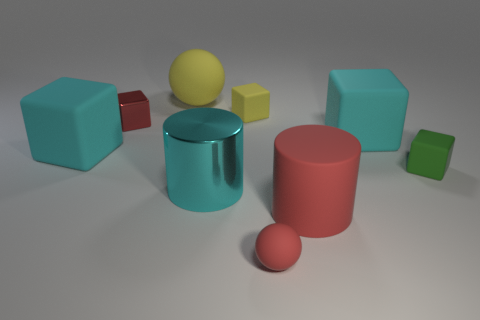There is a cylinder that is made of the same material as the small green object; what size is it?
Offer a very short reply. Large. How many gray shiny objects are the same shape as the small red matte object?
Offer a very short reply. 0. Are there more large cyan metallic cylinders that are to the right of the green thing than large cyan rubber objects that are to the right of the large yellow ball?
Your answer should be compact. No. There is a small metal cube; is its color the same as the cylinder that is to the right of the small red rubber sphere?
Offer a very short reply. Yes. There is a red cylinder that is the same size as the yellow ball; what is it made of?
Your response must be concise. Rubber. How many objects are tiny yellow rubber blocks or red things that are on the left side of the matte cylinder?
Keep it short and to the point. 3. Does the green rubber cube have the same size as the rubber sphere that is left of the tiny matte ball?
Keep it short and to the point. No. How many balls are large blue metal objects or small red rubber things?
Offer a terse response. 1. What number of tiny red objects are behind the red cylinder and on the right side of the yellow matte sphere?
Provide a succinct answer. 0. What number of other things are the same color as the big matte cylinder?
Ensure brevity in your answer.  2. 